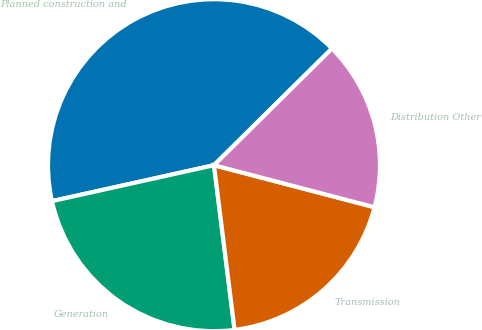Convert chart. <chart><loc_0><loc_0><loc_500><loc_500><pie_chart><fcel>Planned construction and<fcel>Generation<fcel>Transmission<fcel>Distribution Other<nl><fcel>41.06%<fcel>23.51%<fcel>18.94%<fcel>16.49%<nl></chart> 